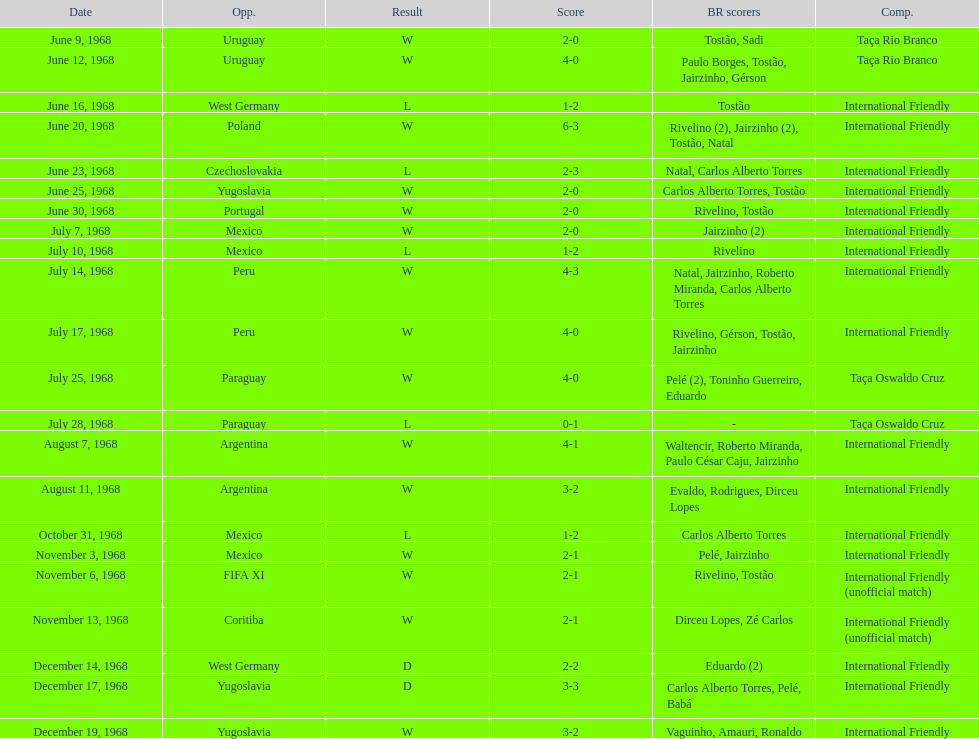What's the cumulative number of ties? 2. 